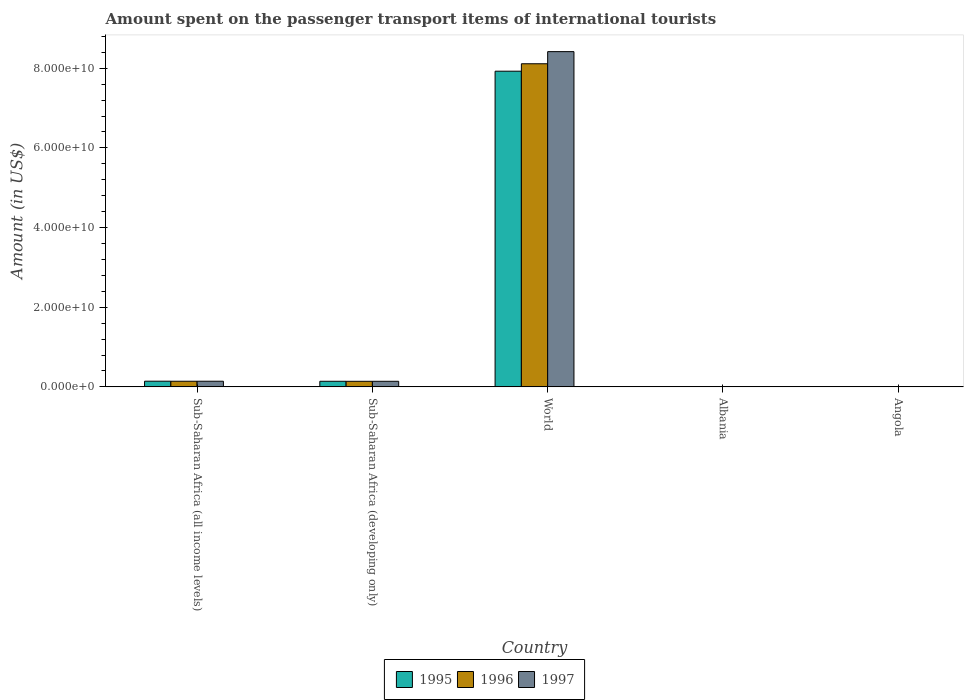How many different coloured bars are there?
Your answer should be very brief. 3. How many groups of bars are there?
Offer a terse response. 5. How many bars are there on the 1st tick from the left?
Keep it short and to the point. 3. What is the label of the 2nd group of bars from the left?
Your answer should be compact. Sub-Saharan Africa (developing only). In how many cases, is the number of bars for a given country not equal to the number of legend labels?
Offer a terse response. 0. What is the amount spent on the passenger transport items of international tourists in 1995 in Sub-Saharan Africa (all income levels)?
Make the answer very short. 1.42e+09. Across all countries, what is the maximum amount spent on the passenger transport items of international tourists in 1997?
Offer a terse response. 8.42e+1. Across all countries, what is the minimum amount spent on the passenger transport items of international tourists in 1996?
Ensure brevity in your answer.  1.30e+07. In which country was the amount spent on the passenger transport items of international tourists in 1997 maximum?
Provide a succinct answer. World. In which country was the amount spent on the passenger transport items of international tourists in 1995 minimum?
Make the answer very short. Albania. What is the total amount spent on the passenger transport items of international tourists in 1997 in the graph?
Ensure brevity in your answer.  8.70e+1. What is the difference between the amount spent on the passenger transport items of international tourists in 1997 in Angola and that in World?
Offer a very short reply. -8.41e+1. What is the difference between the amount spent on the passenger transport items of international tourists in 1995 in Sub-Saharan Africa (all income levels) and the amount spent on the passenger transport items of international tourists in 1997 in Angola?
Ensure brevity in your answer.  1.40e+09. What is the average amount spent on the passenger transport items of international tourists in 1997 per country?
Give a very brief answer. 1.74e+1. What is the difference between the amount spent on the passenger transport items of international tourists of/in 1996 and amount spent on the passenger transport items of international tourists of/in 1995 in Angola?
Keep it short and to the point. -4.50e+05. What is the ratio of the amount spent on the passenger transport items of international tourists in 1996 in Angola to that in Sub-Saharan Africa (all income levels)?
Give a very brief answer. 0.03. Is the difference between the amount spent on the passenger transport items of international tourists in 1996 in Angola and Sub-Saharan Africa (all income levels) greater than the difference between the amount spent on the passenger transport items of international tourists in 1995 in Angola and Sub-Saharan Africa (all income levels)?
Your response must be concise. Yes. What is the difference between the highest and the second highest amount spent on the passenger transport items of international tourists in 1997?
Offer a very short reply. 8.27e+1. What is the difference between the highest and the lowest amount spent on the passenger transport items of international tourists in 1995?
Keep it short and to the point. 7.92e+1. Is the sum of the amount spent on the passenger transport items of international tourists in 1995 in Albania and Angola greater than the maximum amount spent on the passenger transport items of international tourists in 1996 across all countries?
Offer a terse response. No. What does the 2nd bar from the left in Angola represents?
Give a very brief answer. 1996. What does the 2nd bar from the right in Sub-Saharan Africa (all income levels) represents?
Provide a short and direct response. 1996. Are all the bars in the graph horizontal?
Your answer should be very brief. No. What is the difference between two consecutive major ticks on the Y-axis?
Offer a very short reply. 2.00e+1. Are the values on the major ticks of Y-axis written in scientific E-notation?
Keep it short and to the point. Yes. Does the graph contain any zero values?
Offer a very short reply. No. How many legend labels are there?
Your answer should be very brief. 3. How are the legend labels stacked?
Keep it short and to the point. Horizontal. What is the title of the graph?
Provide a succinct answer. Amount spent on the passenger transport items of international tourists. Does "1989" appear as one of the legend labels in the graph?
Give a very brief answer. No. What is the Amount (in US$) in 1995 in Sub-Saharan Africa (all income levels)?
Ensure brevity in your answer.  1.42e+09. What is the Amount (in US$) of 1996 in Sub-Saharan Africa (all income levels)?
Give a very brief answer. 1.41e+09. What is the Amount (in US$) in 1997 in Sub-Saharan Africa (all income levels)?
Offer a very short reply. 1.42e+09. What is the Amount (in US$) in 1995 in Sub-Saharan Africa (developing only)?
Your answer should be compact. 1.41e+09. What is the Amount (in US$) of 1996 in Sub-Saharan Africa (developing only)?
Ensure brevity in your answer.  1.40e+09. What is the Amount (in US$) of 1997 in Sub-Saharan Africa (developing only)?
Ensure brevity in your answer.  1.40e+09. What is the Amount (in US$) of 1995 in World?
Offer a terse response. 7.93e+1. What is the Amount (in US$) in 1996 in World?
Your answer should be very brief. 8.11e+1. What is the Amount (in US$) in 1997 in World?
Your response must be concise. 8.42e+1. What is the Amount (in US$) of 1996 in Albania?
Your answer should be very brief. 1.30e+07. What is the Amount (in US$) in 1997 in Albania?
Your answer should be very brief. 8.00e+06. What is the Amount (in US$) of 1995 in Angola?
Offer a terse response. 3.78e+07. What is the Amount (in US$) in 1996 in Angola?
Provide a succinct answer. 3.74e+07. What is the Amount (in US$) in 1997 in Angola?
Your answer should be very brief. 2.72e+07. Across all countries, what is the maximum Amount (in US$) of 1995?
Your answer should be compact. 7.93e+1. Across all countries, what is the maximum Amount (in US$) of 1996?
Your response must be concise. 8.11e+1. Across all countries, what is the maximum Amount (in US$) in 1997?
Keep it short and to the point. 8.42e+1. Across all countries, what is the minimum Amount (in US$) of 1996?
Offer a very short reply. 1.30e+07. Across all countries, what is the minimum Amount (in US$) in 1997?
Your response must be concise. 8.00e+06. What is the total Amount (in US$) of 1995 in the graph?
Make the answer very short. 8.21e+1. What is the total Amount (in US$) in 1996 in the graph?
Offer a very short reply. 8.40e+1. What is the total Amount (in US$) in 1997 in the graph?
Offer a very short reply. 8.70e+1. What is the difference between the Amount (in US$) in 1995 in Sub-Saharan Africa (all income levels) and that in Sub-Saharan Africa (developing only)?
Provide a succinct answer. 1.78e+07. What is the difference between the Amount (in US$) in 1996 in Sub-Saharan Africa (all income levels) and that in Sub-Saharan Africa (developing only)?
Provide a short and direct response. 1.43e+07. What is the difference between the Amount (in US$) of 1997 in Sub-Saharan Africa (all income levels) and that in Sub-Saharan Africa (developing only)?
Provide a succinct answer. 1.43e+07. What is the difference between the Amount (in US$) in 1995 in Sub-Saharan Africa (all income levels) and that in World?
Give a very brief answer. -7.78e+1. What is the difference between the Amount (in US$) of 1996 in Sub-Saharan Africa (all income levels) and that in World?
Provide a short and direct response. -7.97e+1. What is the difference between the Amount (in US$) of 1997 in Sub-Saharan Africa (all income levels) and that in World?
Your response must be concise. -8.27e+1. What is the difference between the Amount (in US$) in 1995 in Sub-Saharan Africa (all income levels) and that in Albania?
Your answer should be compact. 1.41e+09. What is the difference between the Amount (in US$) of 1996 in Sub-Saharan Africa (all income levels) and that in Albania?
Keep it short and to the point. 1.40e+09. What is the difference between the Amount (in US$) in 1997 in Sub-Saharan Africa (all income levels) and that in Albania?
Your response must be concise. 1.41e+09. What is the difference between the Amount (in US$) in 1995 in Sub-Saharan Africa (all income levels) and that in Angola?
Provide a succinct answer. 1.39e+09. What is the difference between the Amount (in US$) in 1996 in Sub-Saharan Africa (all income levels) and that in Angola?
Offer a terse response. 1.38e+09. What is the difference between the Amount (in US$) in 1997 in Sub-Saharan Africa (all income levels) and that in Angola?
Provide a short and direct response. 1.39e+09. What is the difference between the Amount (in US$) in 1995 in Sub-Saharan Africa (developing only) and that in World?
Your response must be concise. -7.78e+1. What is the difference between the Amount (in US$) in 1996 in Sub-Saharan Africa (developing only) and that in World?
Your response must be concise. -7.97e+1. What is the difference between the Amount (in US$) of 1997 in Sub-Saharan Africa (developing only) and that in World?
Your response must be concise. -8.28e+1. What is the difference between the Amount (in US$) of 1995 in Sub-Saharan Africa (developing only) and that in Albania?
Your answer should be compact. 1.39e+09. What is the difference between the Amount (in US$) in 1996 in Sub-Saharan Africa (developing only) and that in Albania?
Your response must be concise. 1.39e+09. What is the difference between the Amount (in US$) in 1997 in Sub-Saharan Africa (developing only) and that in Albania?
Your answer should be very brief. 1.39e+09. What is the difference between the Amount (in US$) of 1995 in Sub-Saharan Africa (developing only) and that in Angola?
Your answer should be very brief. 1.37e+09. What is the difference between the Amount (in US$) in 1996 in Sub-Saharan Africa (developing only) and that in Angola?
Make the answer very short. 1.36e+09. What is the difference between the Amount (in US$) of 1997 in Sub-Saharan Africa (developing only) and that in Angola?
Offer a very short reply. 1.37e+09. What is the difference between the Amount (in US$) in 1995 in World and that in Albania?
Make the answer very short. 7.92e+1. What is the difference between the Amount (in US$) in 1996 in World and that in Albania?
Your response must be concise. 8.11e+1. What is the difference between the Amount (in US$) in 1997 in World and that in Albania?
Ensure brevity in your answer.  8.42e+1. What is the difference between the Amount (in US$) in 1995 in World and that in Angola?
Your response must be concise. 7.92e+1. What is the difference between the Amount (in US$) of 1996 in World and that in Angola?
Give a very brief answer. 8.11e+1. What is the difference between the Amount (in US$) in 1997 in World and that in Angola?
Provide a short and direct response. 8.41e+1. What is the difference between the Amount (in US$) in 1995 in Albania and that in Angola?
Your response must be concise. -2.58e+07. What is the difference between the Amount (in US$) in 1996 in Albania and that in Angola?
Offer a very short reply. -2.44e+07. What is the difference between the Amount (in US$) in 1997 in Albania and that in Angola?
Provide a short and direct response. -1.92e+07. What is the difference between the Amount (in US$) of 1995 in Sub-Saharan Africa (all income levels) and the Amount (in US$) of 1996 in Sub-Saharan Africa (developing only)?
Provide a short and direct response. 2.39e+07. What is the difference between the Amount (in US$) of 1995 in Sub-Saharan Africa (all income levels) and the Amount (in US$) of 1997 in Sub-Saharan Africa (developing only)?
Make the answer very short. 2.14e+07. What is the difference between the Amount (in US$) of 1996 in Sub-Saharan Africa (all income levels) and the Amount (in US$) of 1997 in Sub-Saharan Africa (developing only)?
Keep it short and to the point. 1.18e+07. What is the difference between the Amount (in US$) in 1995 in Sub-Saharan Africa (all income levels) and the Amount (in US$) in 1996 in World?
Keep it short and to the point. -7.97e+1. What is the difference between the Amount (in US$) of 1995 in Sub-Saharan Africa (all income levels) and the Amount (in US$) of 1997 in World?
Make the answer very short. -8.27e+1. What is the difference between the Amount (in US$) of 1996 in Sub-Saharan Africa (all income levels) and the Amount (in US$) of 1997 in World?
Provide a short and direct response. -8.27e+1. What is the difference between the Amount (in US$) in 1995 in Sub-Saharan Africa (all income levels) and the Amount (in US$) in 1996 in Albania?
Keep it short and to the point. 1.41e+09. What is the difference between the Amount (in US$) in 1995 in Sub-Saharan Africa (all income levels) and the Amount (in US$) in 1997 in Albania?
Give a very brief answer. 1.42e+09. What is the difference between the Amount (in US$) in 1996 in Sub-Saharan Africa (all income levels) and the Amount (in US$) in 1997 in Albania?
Your answer should be compact. 1.41e+09. What is the difference between the Amount (in US$) of 1995 in Sub-Saharan Africa (all income levels) and the Amount (in US$) of 1996 in Angola?
Make the answer very short. 1.39e+09. What is the difference between the Amount (in US$) of 1995 in Sub-Saharan Africa (all income levels) and the Amount (in US$) of 1997 in Angola?
Ensure brevity in your answer.  1.40e+09. What is the difference between the Amount (in US$) in 1996 in Sub-Saharan Africa (all income levels) and the Amount (in US$) in 1997 in Angola?
Your response must be concise. 1.39e+09. What is the difference between the Amount (in US$) of 1995 in Sub-Saharan Africa (developing only) and the Amount (in US$) of 1996 in World?
Provide a succinct answer. -7.97e+1. What is the difference between the Amount (in US$) in 1995 in Sub-Saharan Africa (developing only) and the Amount (in US$) in 1997 in World?
Ensure brevity in your answer.  -8.28e+1. What is the difference between the Amount (in US$) in 1996 in Sub-Saharan Africa (developing only) and the Amount (in US$) in 1997 in World?
Offer a very short reply. -8.28e+1. What is the difference between the Amount (in US$) of 1995 in Sub-Saharan Africa (developing only) and the Amount (in US$) of 1996 in Albania?
Offer a very short reply. 1.39e+09. What is the difference between the Amount (in US$) in 1995 in Sub-Saharan Africa (developing only) and the Amount (in US$) in 1997 in Albania?
Offer a very short reply. 1.40e+09. What is the difference between the Amount (in US$) in 1996 in Sub-Saharan Africa (developing only) and the Amount (in US$) in 1997 in Albania?
Your answer should be compact. 1.39e+09. What is the difference between the Amount (in US$) in 1995 in Sub-Saharan Africa (developing only) and the Amount (in US$) in 1996 in Angola?
Make the answer very short. 1.37e+09. What is the difference between the Amount (in US$) of 1995 in Sub-Saharan Africa (developing only) and the Amount (in US$) of 1997 in Angola?
Offer a very short reply. 1.38e+09. What is the difference between the Amount (in US$) in 1996 in Sub-Saharan Africa (developing only) and the Amount (in US$) in 1997 in Angola?
Give a very brief answer. 1.37e+09. What is the difference between the Amount (in US$) in 1995 in World and the Amount (in US$) in 1996 in Albania?
Make the answer very short. 7.92e+1. What is the difference between the Amount (in US$) of 1995 in World and the Amount (in US$) of 1997 in Albania?
Give a very brief answer. 7.92e+1. What is the difference between the Amount (in US$) of 1996 in World and the Amount (in US$) of 1997 in Albania?
Your answer should be very brief. 8.11e+1. What is the difference between the Amount (in US$) in 1995 in World and the Amount (in US$) in 1996 in Angola?
Your response must be concise. 7.92e+1. What is the difference between the Amount (in US$) in 1995 in World and the Amount (in US$) in 1997 in Angola?
Make the answer very short. 7.92e+1. What is the difference between the Amount (in US$) of 1996 in World and the Amount (in US$) of 1997 in Angola?
Your answer should be very brief. 8.11e+1. What is the difference between the Amount (in US$) in 1995 in Albania and the Amount (in US$) in 1996 in Angola?
Make the answer very short. -2.54e+07. What is the difference between the Amount (in US$) in 1995 in Albania and the Amount (in US$) in 1997 in Angola?
Keep it short and to the point. -1.52e+07. What is the difference between the Amount (in US$) in 1996 in Albania and the Amount (in US$) in 1997 in Angola?
Keep it short and to the point. -1.42e+07. What is the average Amount (in US$) of 1995 per country?
Make the answer very short. 1.64e+1. What is the average Amount (in US$) in 1996 per country?
Your answer should be very brief. 1.68e+1. What is the average Amount (in US$) of 1997 per country?
Your answer should be compact. 1.74e+1. What is the difference between the Amount (in US$) in 1995 and Amount (in US$) in 1996 in Sub-Saharan Africa (all income levels)?
Provide a succinct answer. 9.58e+06. What is the difference between the Amount (in US$) of 1995 and Amount (in US$) of 1997 in Sub-Saharan Africa (all income levels)?
Keep it short and to the point. 7.08e+06. What is the difference between the Amount (in US$) in 1996 and Amount (in US$) in 1997 in Sub-Saharan Africa (all income levels)?
Give a very brief answer. -2.51e+06. What is the difference between the Amount (in US$) of 1995 and Amount (in US$) of 1996 in Sub-Saharan Africa (developing only)?
Ensure brevity in your answer.  6.01e+06. What is the difference between the Amount (in US$) in 1995 and Amount (in US$) in 1997 in Sub-Saharan Africa (developing only)?
Provide a short and direct response. 3.52e+06. What is the difference between the Amount (in US$) in 1996 and Amount (in US$) in 1997 in Sub-Saharan Africa (developing only)?
Your response must be concise. -2.49e+06. What is the difference between the Amount (in US$) in 1995 and Amount (in US$) in 1996 in World?
Make the answer very short. -1.87e+09. What is the difference between the Amount (in US$) of 1995 and Amount (in US$) of 1997 in World?
Your answer should be compact. -4.91e+09. What is the difference between the Amount (in US$) in 1996 and Amount (in US$) in 1997 in World?
Your answer should be compact. -3.04e+09. What is the difference between the Amount (in US$) of 1995 and Amount (in US$) of 1996 in Albania?
Provide a short and direct response. -1.00e+06. What is the difference between the Amount (in US$) of 1996 and Amount (in US$) of 1997 in Albania?
Your response must be concise. 5.00e+06. What is the difference between the Amount (in US$) of 1995 and Amount (in US$) of 1997 in Angola?
Give a very brief answer. 1.06e+07. What is the difference between the Amount (in US$) in 1996 and Amount (in US$) in 1997 in Angola?
Keep it short and to the point. 1.02e+07. What is the ratio of the Amount (in US$) in 1995 in Sub-Saharan Africa (all income levels) to that in Sub-Saharan Africa (developing only)?
Provide a short and direct response. 1.01. What is the ratio of the Amount (in US$) of 1996 in Sub-Saharan Africa (all income levels) to that in Sub-Saharan Africa (developing only)?
Offer a very short reply. 1.01. What is the ratio of the Amount (in US$) of 1997 in Sub-Saharan Africa (all income levels) to that in Sub-Saharan Africa (developing only)?
Keep it short and to the point. 1.01. What is the ratio of the Amount (in US$) in 1995 in Sub-Saharan Africa (all income levels) to that in World?
Keep it short and to the point. 0.02. What is the ratio of the Amount (in US$) of 1996 in Sub-Saharan Africa (all income levels) to that in World?
Give a very brief answer. 0.02. What is the ratio of the Amount (in US$) of 1997 in Sub-Saharan Africa (all income levels) to that in World?
Offer a very short reply. 0.02. What is the ratio of the Amount (in US$) in 1995 in Sub-Saharan Africa (all income levels) to that in Albania?
Make the answer very short. 118.6. What is the ratio of the Amount (in US$) in 1996 in Sub-Saharan Africa (all income levels) to that in Albania?
Offer a terse response. 108.74. What is the ratio of the Amount (in US$) of 1997 in Sub-Saharan Africa (all income levels) to that in Albania?
Provide a succinct answer. 177.02. What is the ratio of the Amount (in US$) of 1995 in Sub-Saharan Africa (all income levels) to that in Angola?
Provide a succinct answer. 37.63. What is the ratio of the Amount (in US$) in 1996 in Sub-Saharan Africa (all income levels) to that in Angola?
Give a very brief answer. 37.83. What is the ratio of the Amount (in US$) in 1997 in Sub-Saharan Africa (all income levels) to that in Angola?
Offer a very short reply. 52.06. What is the ratio of the Amount (in US$) in 1995 in Sub-Saharan Africa (developing only) to that in World?
Your response must be concise. 0.02. What is the ratio of the Amount (in US$) in 1996 in Sub-Saharan Africa (developing only) to that in World?
Your answer should be very brief. 0.02. What is the ratio of the Amount (in US$) in 1997 in Sub-Saharan Africa (developing only) to that in World?
Provide a succinct answer. 0.02. What is the ratio of the Amount (in US$) of 1995 in Sub-Saharan Africa (developing only) to that in Albania?
Provide a short and direct response. 117.11. What is the ratio of the Amount (in US$) in 1996 in Sub-Saharan Africa (developing only) to that in Albania?
Offer a very short reply. 107.64. What is the ratio of the Amount (in US$) of 1997 in Sub-Saharan Africa (developing only) to that in Albania?
Your answer should be compact. 175.23. What is the ratio of the Amount (in US$) of 1995 in Sub-Saharan Africa (developing only) to that in Angola?
Give a very brief answer. 37.16. What is the ratio of the Amount (in US$) in 1996 in Sub-Saharan Africa (developing only) to that in Angola?
Your answer should be compact. 37.45. What is the ratio of the Amount (in US$) of 1997 in Sub-Saharan Africa (developing only) to that in Angola?
Your answer should be very brief. 51.54. What is the ratio of the Amount (in US$) of 1995 in World to that in Albania?
Make the answer very short. 6604.42. What is the ratio of the Amount (in US$) in 1996 in World to that in Albania?
Keep it short and to the point. 6239.88. What is the ratio of the Amount (in US$) in 1997 in World to that in Albania?
Your answer should be compact. 1.05e+04. What is the ratio of the Amount (in US$) in 1995 in World to that in Angola?
Provide a succinct answer. 2095.59. What is the ratio of the Amount (in US$) of 1996 in World to that in Angola?
Provide a short and direct response. 2170.74. What is the ratio of the Amount (in US$) in 1997 in World to that in Angola?
Provide a succinct answer. 3094.22. What is the ratio of the Amount (in US$) in 1995 in Albania to that in Angola?
Your answer should be compact. 0.32. What is the ratio of the Amount (in US$) of 1996 in Albania to that in Angola?
Offer a terse response. 0.35. What is the ratio of the Amount (in US$) in 1997 in Albania to that in Angola?
Give a very brief answer. 0.29. What is the difference between the highest and the second highest Amount (in US$) in 1995?
Offer a very short reply. 7.78e+1. What is the difference between the highest and the second highest Amount (in US$) in 1996?
Make the answer very short. 7.97e+1. What is the difference between the highest and the second highest Amount (in US$) in 1997?
Make the answer very short. 8.27e+1. What is the difference between the highest and the lowest Amount (in US$) in 1995?
Ensure brevity in your answer.  7.92e+1. What is the difference between the highest and the lowest Amount (in US$) of 1996?
Make the answer very short. 8.11e+1. What is the difference between the highest and the lowest Amount (in US$) in 1997?
Keep it short and to the point. 8.42e+1. 